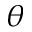<formula> <loc_0><loc_0><loc_500><loc_500>\ v _ { \theta }</formula> 